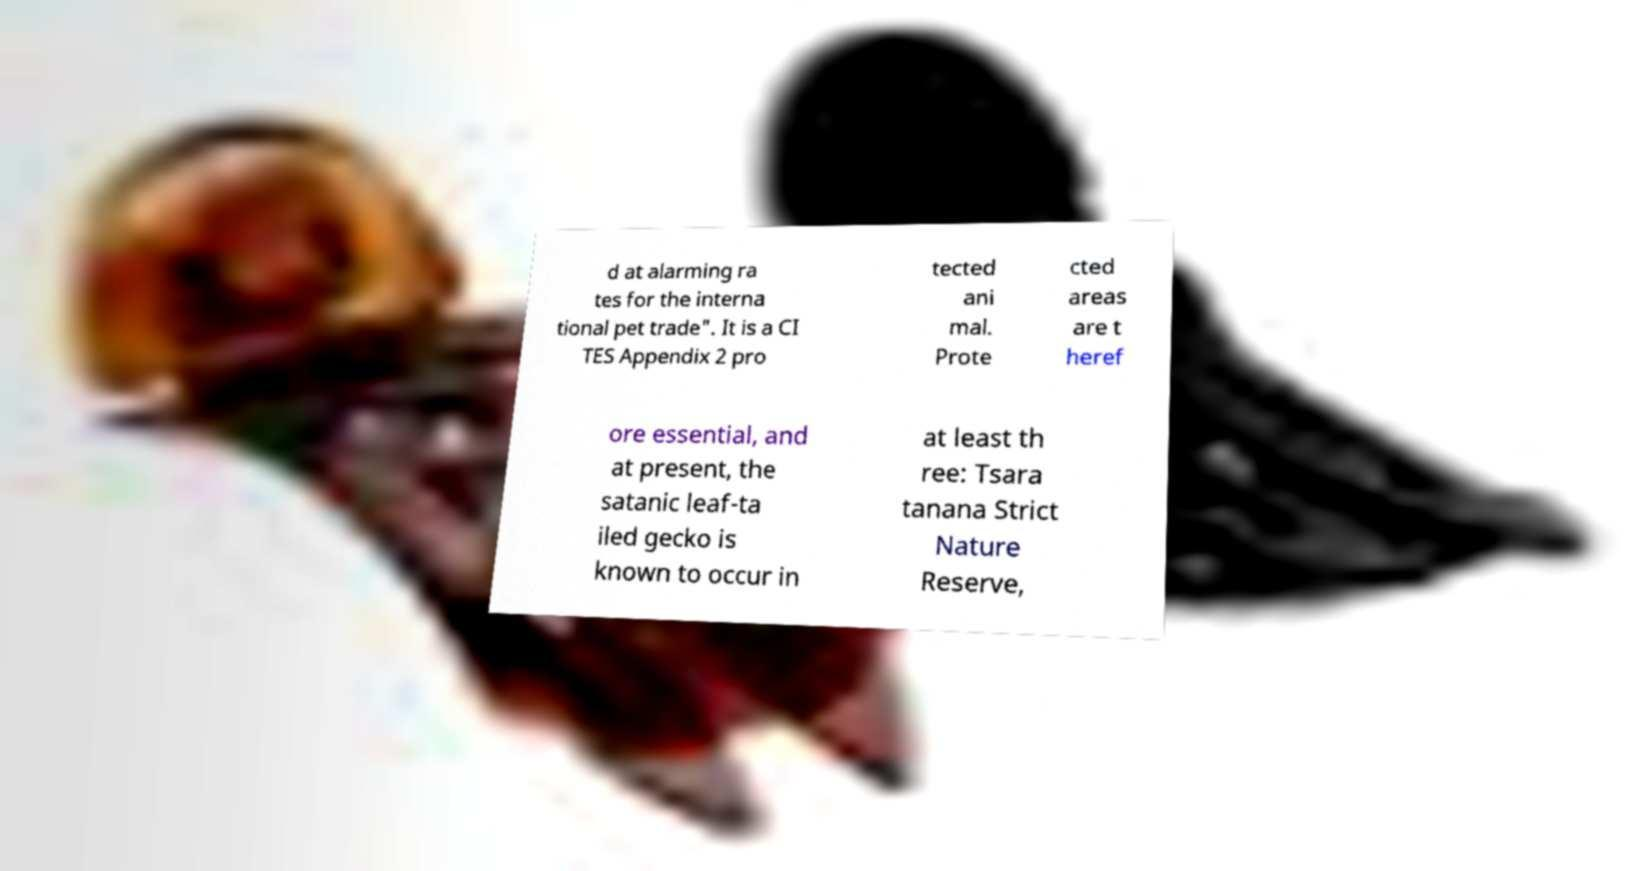There's text embedded in this image that I need extracted. Can you transcribe it verbatim? d at alarming ra tes for the interna tional pet trade". It is a CI TES Appendix 2 pro tected ani mal. Prote cted areas are t heref ore essential, and at present, the satanic leaf-ta iled gecko is known to occur in at least th ree: Tsara tanana Strict Nature Reserve, 